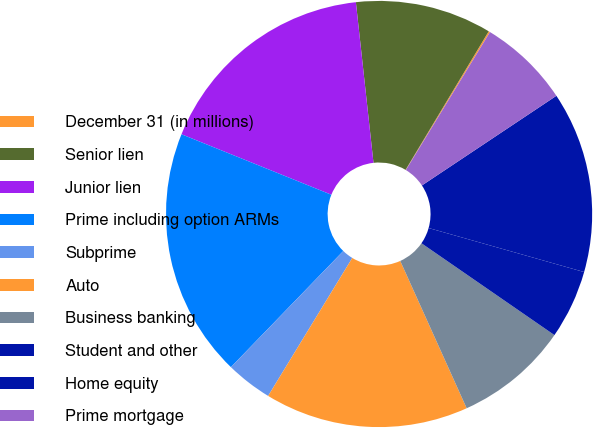Convert chart to OTSL. <chart><loc_0><loc_0><loc_500><loc_500><pie_chart><fcel>December 31 (in millions)<fcel>Senior lien<fcel>Junior lien<fcel>Prime including option ARMs<fcel>Subprime<fcel>Auto<fcel>Business banking<fcel>Student and other<fcel>Home equity<fcel>Prime mortgage<nl><fcel>0.11%<fcel>10.34%<fcel>17.16%<fcel>18.87%<fcel>3.52%<fcel>15.46%<fcel>8.64%<fcel>5.23%<fcel>13.75%<fcel>6.93%<nl></chart> 